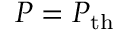<formula> <loc_0><loc_0><loc_500><loc_500>P = P _ { t h }</formula> 